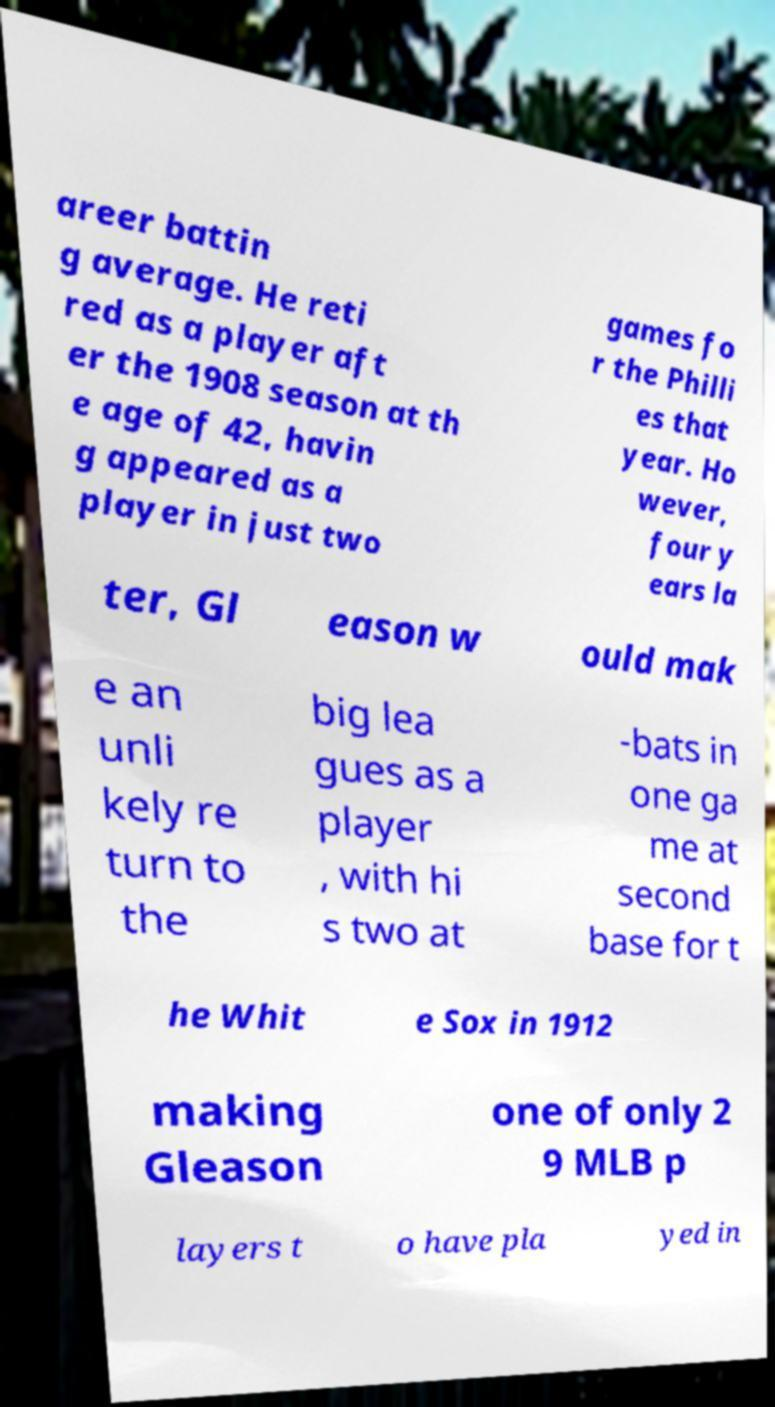What messages or text are displayed in this image? I need them in a readable, typed format. areer battin g average. He reti red as a player aft er the 1908 season at th e age of 42, havin g appeared as a player in just two games fo r the Philli es that year. Ho wever, four y ears la ter, Gl eason w ould mak e an unli kely re turn to the big lea gues as a player , with hi s two at -bats in one ga me at second base for t he Whit e Sox in 1912 making Gleason one of only 2 9 MLB p layers t o have pla yed in 